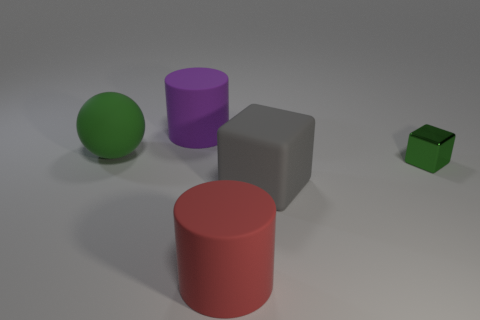Add 4 green shiny objects. How many objects exist? 9 Subtract all cubes. How many objects are left? 3 Add 3 big red cylinders. How many big red cylinders exist? 4 Subtract 1 gray cubes. How many objects are left? 4 Subtract all big cylinders. Subtract all matte cylinders. How many objects are left? 1 Add 5 large red matte things. How many large red matte things are left? 6 